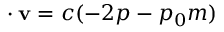Convert formula to latex. <formula><loc_0><loc_0><loc_500><loc_500>\nabla \cdot v = c ( - 2 p - p _ { 0 } m )</formula> 